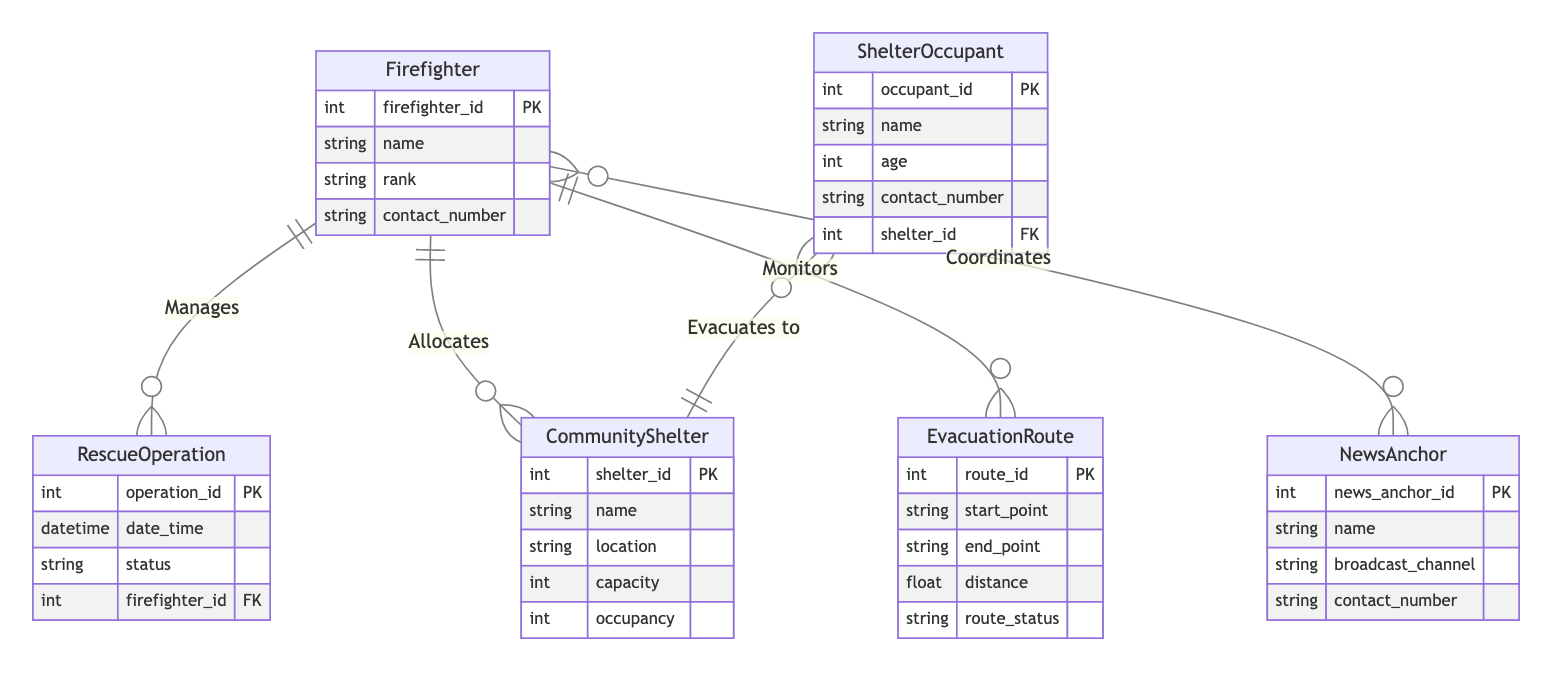What are the entities represented in the diagram? The diagram includes five primary entities: Firefighter, NewsAnchor, CommunityShelter, EvacuationRoute, RescueOperation, and ShelterOccupant. By identifying each square in the diagram, we can list these entities directly as they are clearly labeled.
Answer: Firefighter, NewsAnchor, CommunityShelter, EvacuationRoute, RescueOperation, ShelterOccupant How many attributes does the CommunityShelter entity have? The CommunityShelter entity has five attributes: shelter_id, name, location, capacity, and occupancy. By counting the listed attributes in the entity's box, we find this total.
Answer: 5 What type of relationship exists between Firefighter and NewsAnchor? The relationship between Firefighter and NewsAnchor is many-to-many, as indicated by the line connecting the two entities marked with a 'o{'. This relationship type is described explicitly in the relationships section of the diagram.
Answer: many-to-many How many evacuation routes can a firefighter monitor? Each firefighter can monitor multiple evacuation routes, thus creating a one-to-many relationship based on the 'Monitors' line. This information is inferred from the relational structure shown in the diagram indicating that one entity relates to many others.
Answer: many Who manages a rescue operation? A firefighter manages a rescue operation. This is indicated by the line labeled "Manages" connecting the Firefighter entity to the RescueOperation entity, representing a one-to-many relationship.
Answer: Firefighter What is the maximum number of occupants a shelter can host? The maximum number of occupants a shelter can host is defined by its capacity attribute. This data can be sourced from the CommunityShelter entity by reviewing its attributes where the capacity is specifically mentioned.
Answer: capacity How many relationships are defined for the Firefighter entity? The Firefighter entity has four defined relationships: Manages (RescueOperation), Allocates (CommunityShelter), Monitors (EvacuationRoute), and Coordinates (NewsAnchor). By identifying each line extending from the Firefighter entity, we can count to find the total number of relationships.
Answer: 4 Which entity has a foreign key reference from ShelterOccupant? The ShelterOccupant entity has a foreign key reference to the CommunityShelter entity. This is indicated in the attributes of ShelterOccupant where 'shelter_id' is marked as FK, representing a relationship to CommunityShelter.
Answer: CommunityShelter What does it mean when a firefighter allocates to a community shelter? When a firefighter allocates to a community shelter, it indicates a one-to-many relationship. This means one firefighter can be responsible for multiple community shelters, as defined by the relationship named 'Allocates' between these two entities in the diagram.
Answer: One-to-many 